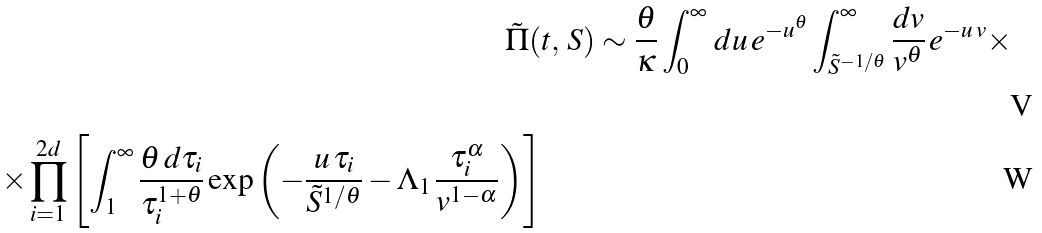<formula> <loc_0><loc_0><loc_500><loc_500>\tilde { \Pi } ( & t , \, S ) \sim \frac { \theta } { \kappa } \int _ { 0 } ^ { \infty } \, d u \, e ^ { - u ^ { \theta } } \int _ { \tilde { S } ^ { - 1 / \theta } } ^ { \infty } \frac { d v } { v ^ { \theta } } \, e ^ { - u \, v } \times \\ \times \prod _ { i = 1 } ^ { 2 d } \left [ \int _ { 1 } ^ { \infty } \frac { \theta \, d \tau _ { i } } { \tau _ { i } ^ { 1 + \theta } } \exp \left ( - \frac { u \, \tau _ { i } } { \tilde { S } ^ { 1 / \theta } } - \Lambda _ { 1 } \, \frac { \tau _ { i } ^ { \alpha } } { v ^ { 1 - \alpha } } \right ) \right ]</formula> 